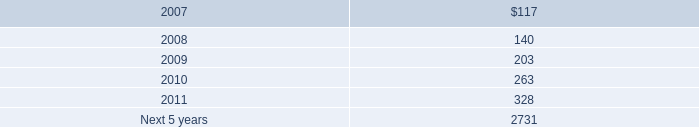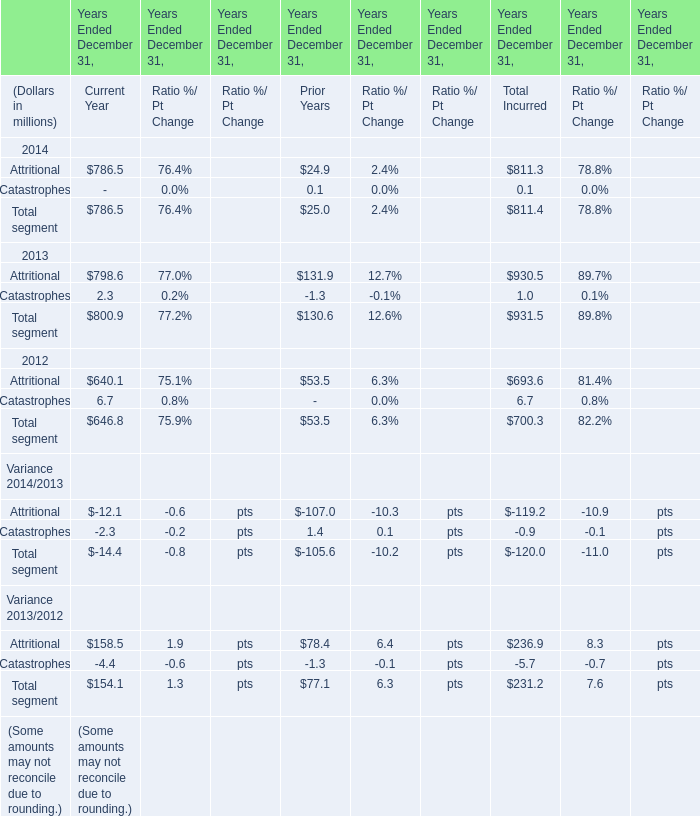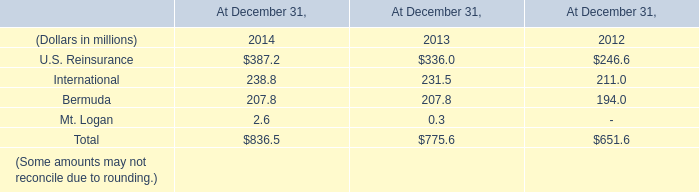what is the percentage change in the capital and statutory surplus from 2005 to 2006? 
Computations: ((2704.1 - 2327.6) / 2327.6)
Answer: 0.16175. 